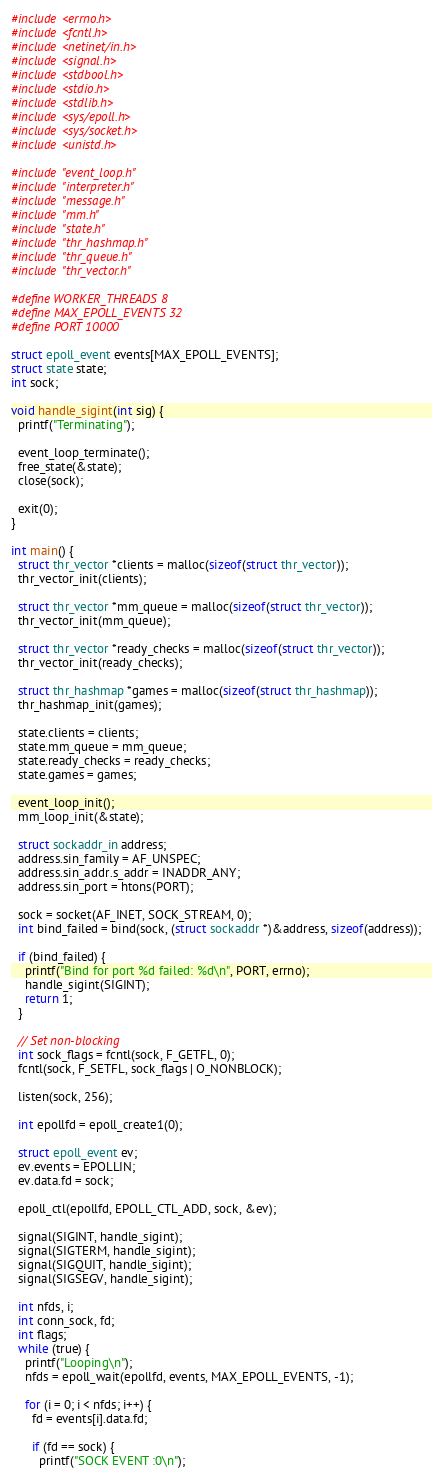<code> <loc_0><loc_0><loc_500><loc_500><_C_>#include <errno.h>
#include <fcntl.h>
#include <netinet/in.h>
#include <signal.h>
#include <stdbool.h>
#include <stdio.h>
#include <stdlib.h>
#include <sys/epoll.h>
#include <sys/socket.h>
#include <unistd.h>

#include "event_loop.h"
#include "interpreter.h"
#include "message.h"
#include "mm.h"
#include "state.h"
#include "thr_hashmap.h"
#include "thr_queue.h"
#include "thr_vector.h"

#define WORKER_THREADS 8
#define MAX_EPOLL_EVENTS 32
#define PORT 10000

struct epoll_event events[MAX_EPOLL_EVENTS];
struct state state;
int sock;

void handle_sigint(int sig) {
  printf("Terminating");

  event_loop_terminate();
  free_state(&state);
  close(sock);

  exit(0);
}

int main() {
  struct thr_vector *clients = malloc(sizeof(struct thr_vector));
  thr_vector_init(clients);

  struct thr_vector *mm_queue = malloc(sizeof(struct thr_vector));
  thr_vector_init(mm_queue);

  struct thr_vector *ready_checks = malloc(sizeof(struct thr_vector));
  thr_vector_init(ready_checks);

  struct thr_hashmap *games = malloc(sizeof(struct thr_hashmap));
  thr_hashmap_init(games);

  state.clients = clients;
  state.mm_queue = mm_queue;
  state.ready_checks = ready_checks;
  state.games = games;

  event_loop_init();
  mm_loop_init(&state);

  struct sockaddr_in address;
  address.sin_family = AF_UNSPEC;
  address.sin_addr.s_addr = INADDR_ANY;
  address.sin_port = htons(PORT);

  sock = socket(AF_INET, SOCK_STREAM, 0);
  int bind_failed = bind(sock, (struct sockaddr *)&address, sizeof(address));

  if (bind_failed) {
    printf("Bind for port %d failed: %d\n", PORT, errno);
    handle_sigint(SIGINT);
    return 1;
  }

  // Set non-blocking
  int sock_flags = fcntl(sock, F_GETFL, 0);
  fcntl(sock, F_SETFL, sock_flags | O_NONBLOCK);

  listen(sock, 256);

  int epollfd = epoll_create1(0);

  struct epoll_event ev;
  ev.events = EPOLLIN;
  ev.data.fd = sock;

  epoll_ctl(epollfd, EPOLL_CTL_ADD, sock, &ev);

  signal(SIGINT, handle_sigint);
  signal(SIGTERM, handle_sigint);
  signal(SIGQUIT, handle_sigint);
  signal(SIGSEGV, handle_sigint);

  int nfds, i;
  int conn_sock, fd;
  int flags;
  while (true) {
    printf("Looping\n");
    nfds = epoll_wait(epollfd, events, MAX_EPOLL_EVENTS, -1);

    for (i = 0; i < nfds; i++) {
      fd = events[i].data.fd;

      if (fd == sock) {
        printf("SOCK EVENT :0\n");
</code> 